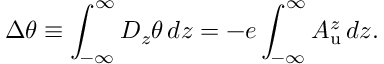Convert formula to latex. <formula><loc_0><loc_0><loc_500><loc_500>\Delta \theta \equiv \int _ { - \infty } ^ { \infty } D _ { z } \theta \, d z = - e \int _ { - \infty } ^ { \infty } A _ { u } ^ { z } \, d z .</formula> 